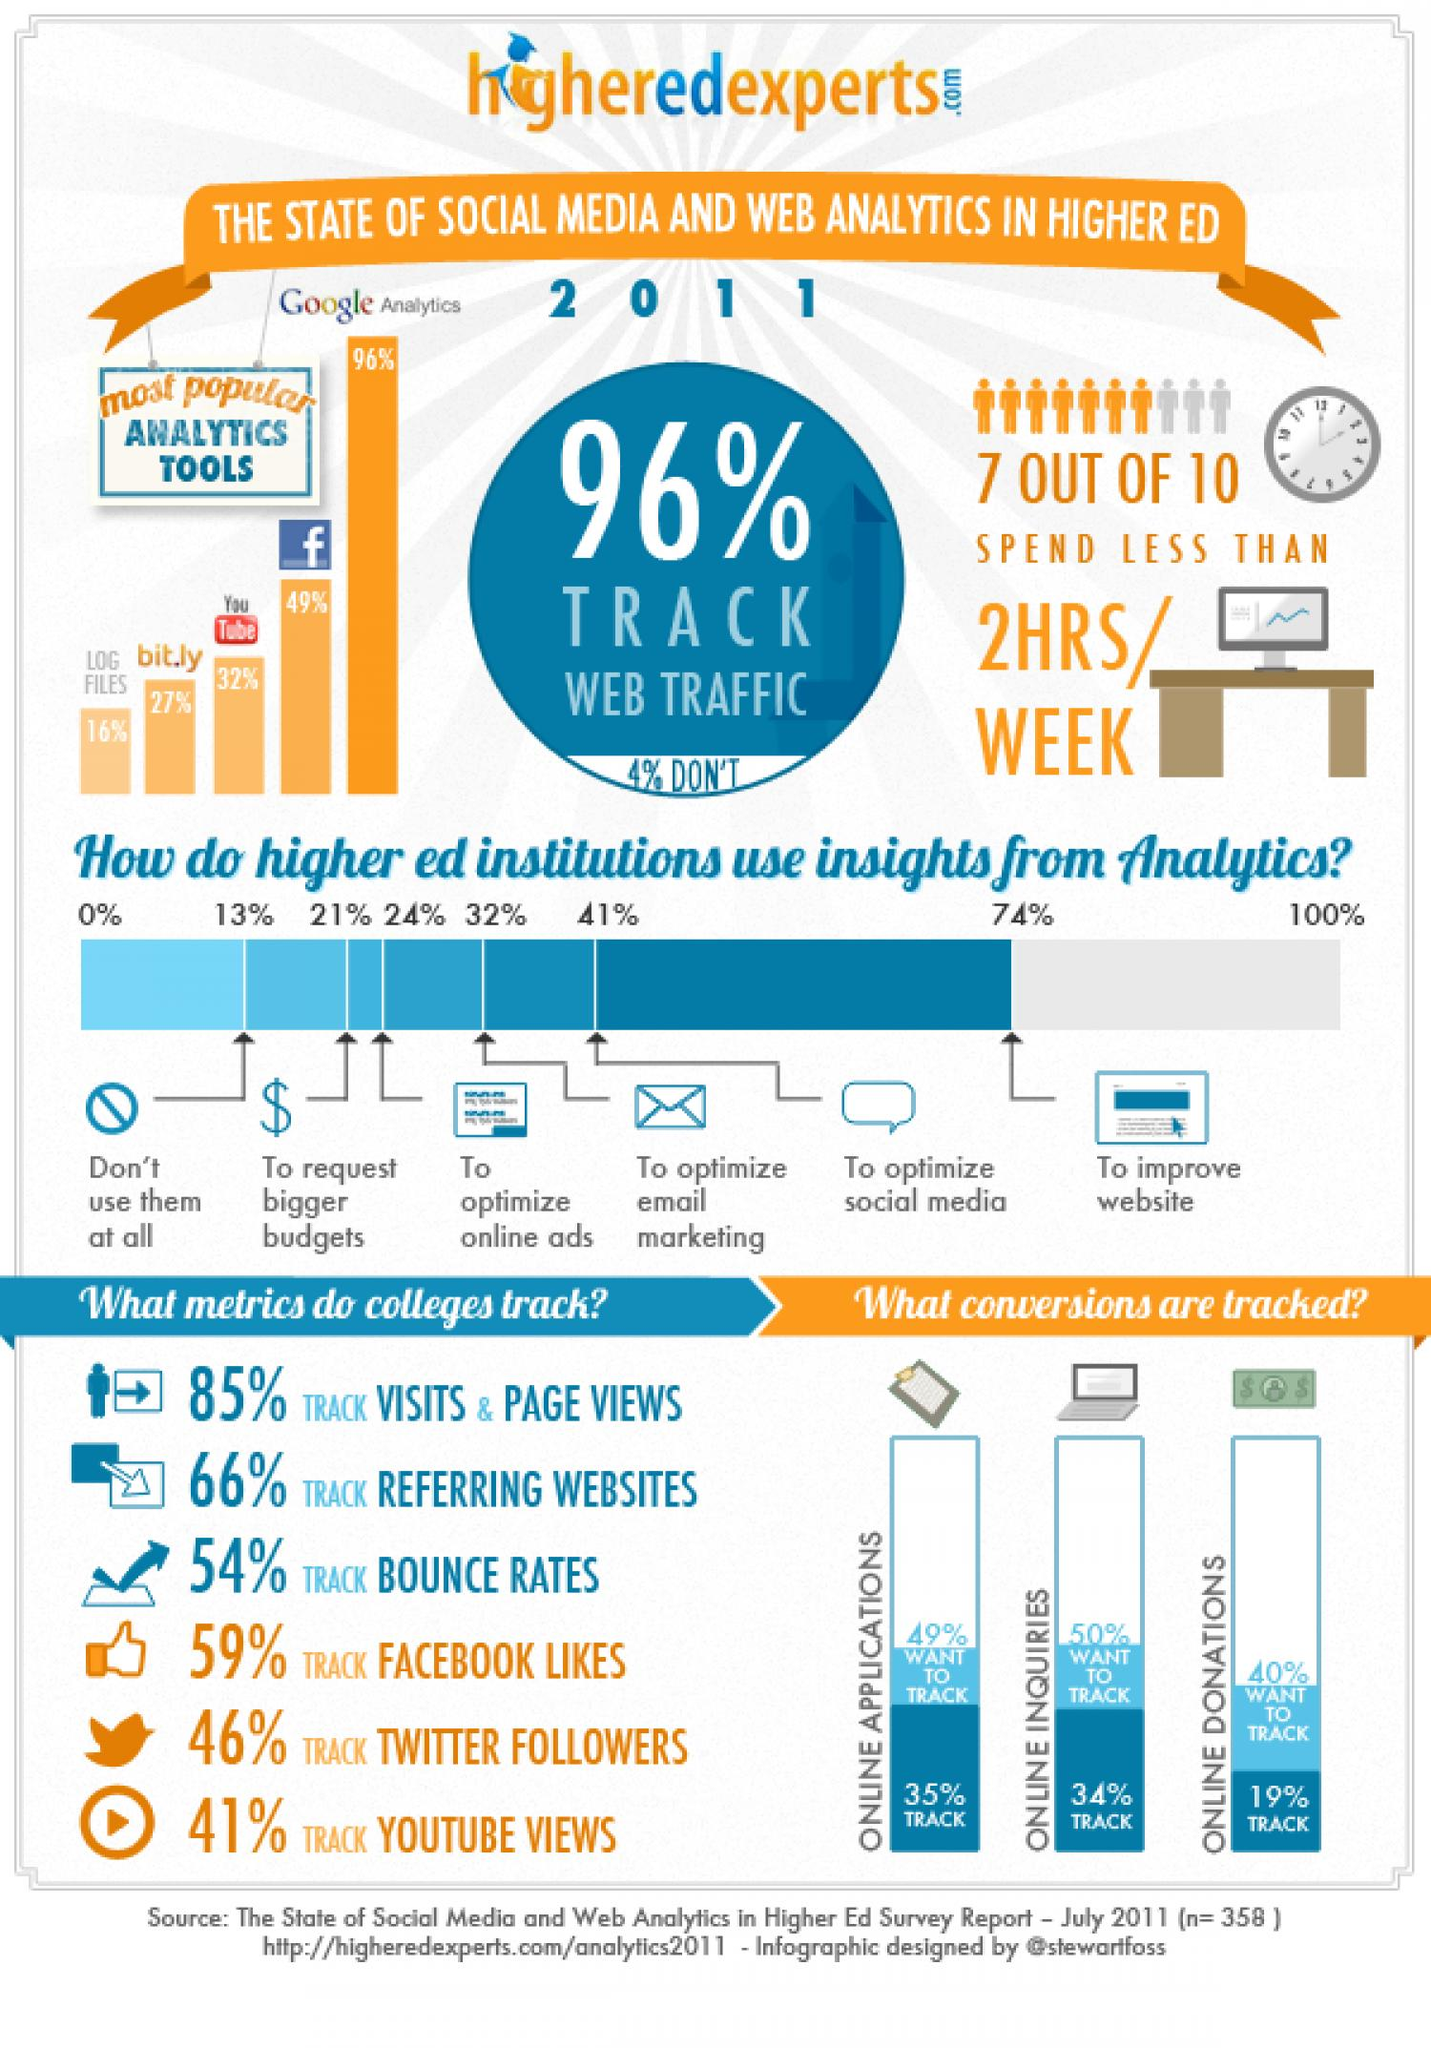Outline some significant characteristics in this image. Thirty-four percent of online enquiries were tracked. According to the tracked online donations, 19% were recorded. A significant majority, or 81%, use Facebook and YouTube as analytics tools. According to the provided data, 43% of respondents use log files and bit.ly as analytics tools. According to a survey, 96% of people use web traffic to track. 